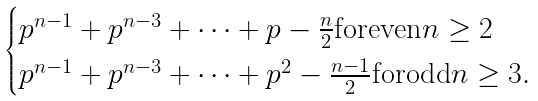<formula> <loc_0><loc_0><loc_500><loc_500>\begin{cases} p ^ { n - 1 } + p ^ { n - 3 } + \cdots + p - \frac { n } { 2 } \text {foreven} n \geq 2 \\ p ^ { n - 1 } + p ^ { n - 3 } + \cdots + p ^ { 2 } - \frac { n - 1 } { 2 } \text {forodd} n \geq 3 . \end{cases}</formula> 